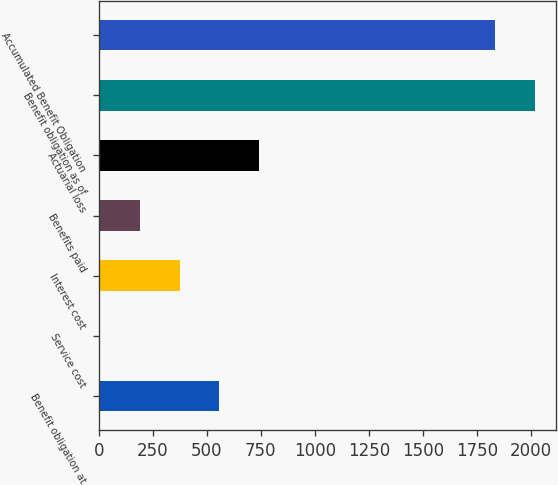Convert chart. <chart><loc_0><loc_0><loc_500><loc_500><bar_chart><fcel>Benefit obligation at<fcel>Service cost<fcel>Interest cost<fcel>Benefits paid<fcel>Actuarial loss<fcel>Benefit obligation as of<fcel>Accumulated Benefit Obligation<nl><fcel>558.1<fcel>7<fcel>374.4<fcel>190.7<fcel>741.8<fcel>2017.7<fcel>1834<nl></chart> 